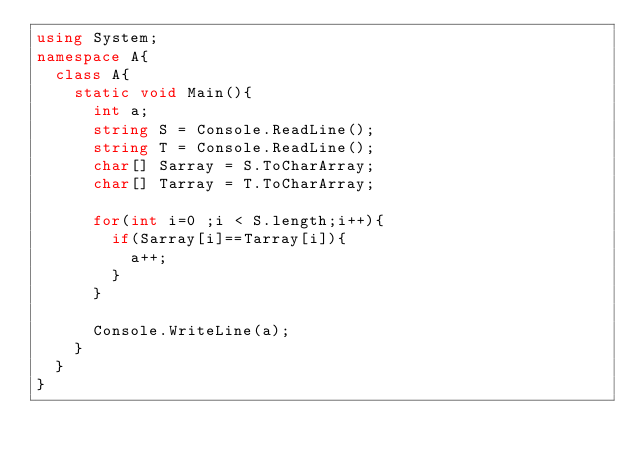Convert code to text. <code><loc_0><loc_0><loc_500><loc_500><_C#_>using System;
namespace A{
  class A{
    static void Main(){
      int a;
      string S = Console.ReadLine();
      string T = Console.ReadLine();
      char[] Sarray = S.ToCharArray;
      char[] Tarray = T.ToCharArray;
      
      for(int i=0 ;i < S.length;i++){
        if(Sarray[i]==Tarray[i]){
          a++;
        }
      }
      
      Console.WriteLine(a);
    }
  }
}
</code> 